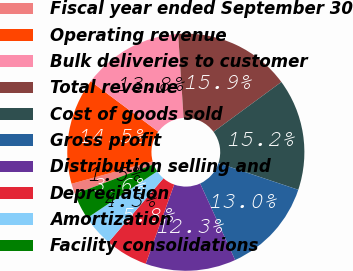Convert chart to OTSL. <chart><loc_0><loc_0><loc_500><loc_500><pie_chart><fcel>Fiscal year ended September 30<fcel>Operating revenue<fcel>Bulk deliveries to customer<fcel>Total revenue<fcel>Cost of goods sold<fcel>Gross profit<fcel>Distribution selling and<fcel>Depreciation<fcel>Amortization<fcel>Facility consolidations<nl><fcel>1.45%<fcel>14.49%<fcel>13.77%<fcel>15.94%<fcel>15.22%<fcel>13.04%<fcel>12.32%<fcel>5.8%<fcel>4.35%<fcel>3.62%<nl></chart> 